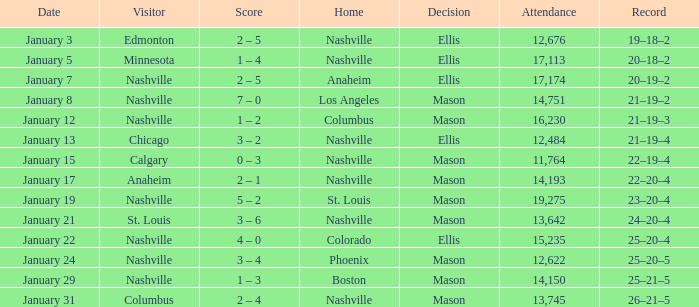On January 15, what was the most in attendance? 11764.0. 